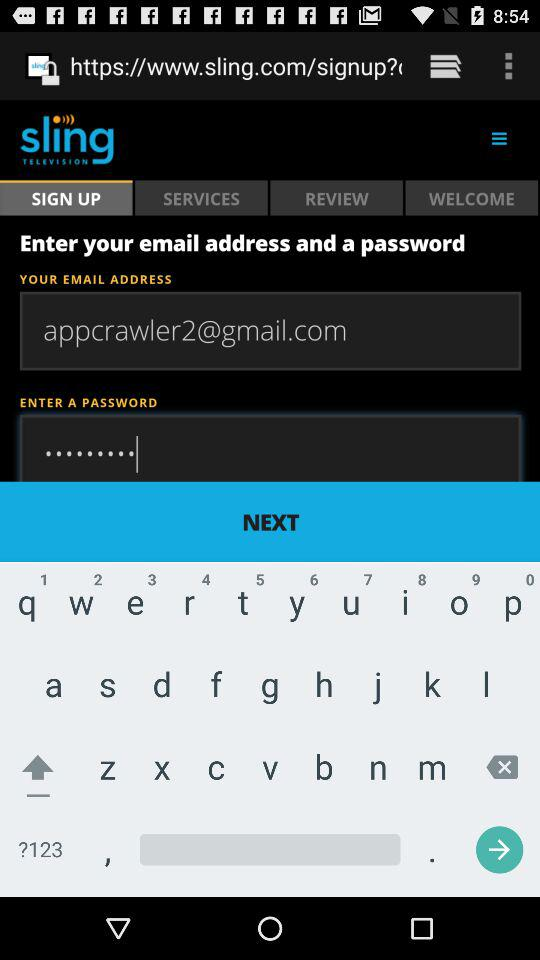What is the contact number? The contact number is 1-888-348-1248. 